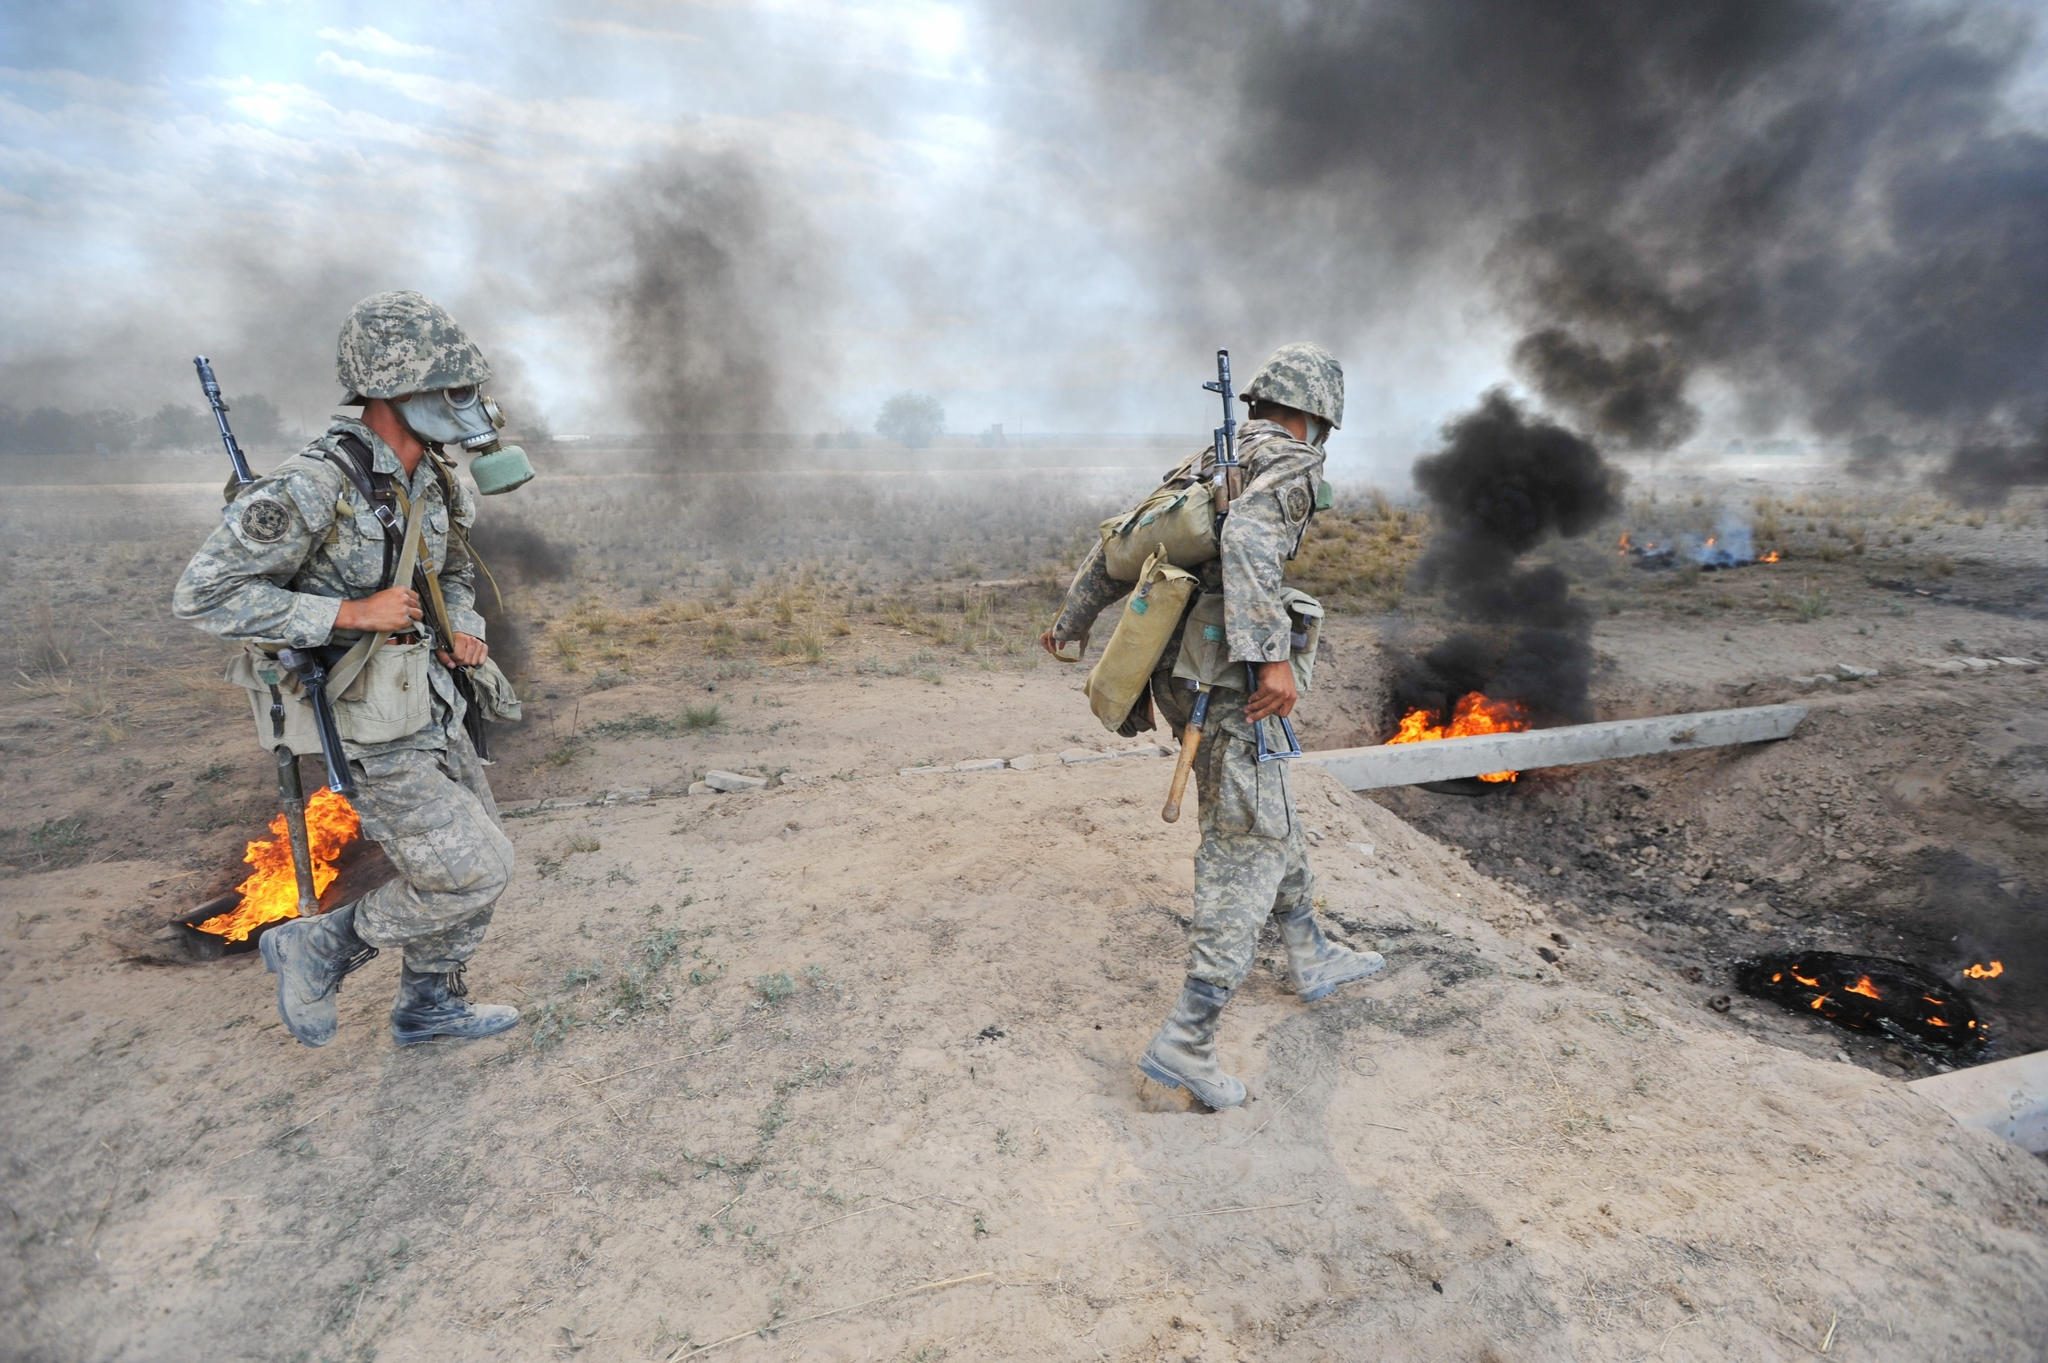How might the surrounding environment impact the soldiers' tactics and strategy? The surrounding environment, filled with smoke, flames, and debris, would significantly impact the soldiers' tactics and strategy. Poor visibility due to smoke would necessitate heightened reliance on communication and possibly infrared or thermal imaging for navigation and threat detection. The flames and debris indicate potential hazards, so the soldiers must be cautious and deliberate in their movements to avoid injuries or triggering additional explosions. Their strategy would likely include rapid assessment of the area, securing key points, and maintaining readiness for any sudden changes in the situation. Adapting to the environment would be crucial for both their safety and mission success. Describe a scenario where the presence of flames and smoke could provide a tactical advantage. Flames and smoke in a conflict area could offer tactical advantages by providing natural cover and obscuring the soldiers' movements from enemy forces. For example, soldiers could use the smoke to conceal their approach, allowing them to get closer to enemy positions without being detected. The chaos and confusion caused by the fire could disrupt enemy defenses and communications, making it easier for soldiers to execute surprise attacks or flanking maneuvers. Additionally, the flames could force enemies out of fortified positions, making them more vulnerable to capture or engagement. 